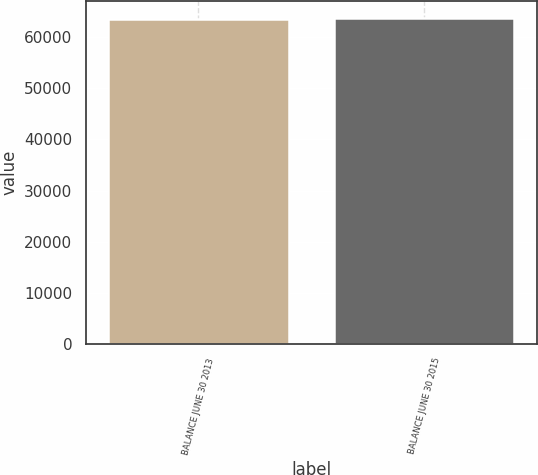<chart> <loc_0><loc_0><loc_500><loc_500><bar_chart><fcel>BALANCE JUNE 30 2013<fcel>BALANCE JUNE 30 2015<nl><fcel>63538<fcel>63852<nl></chart> 